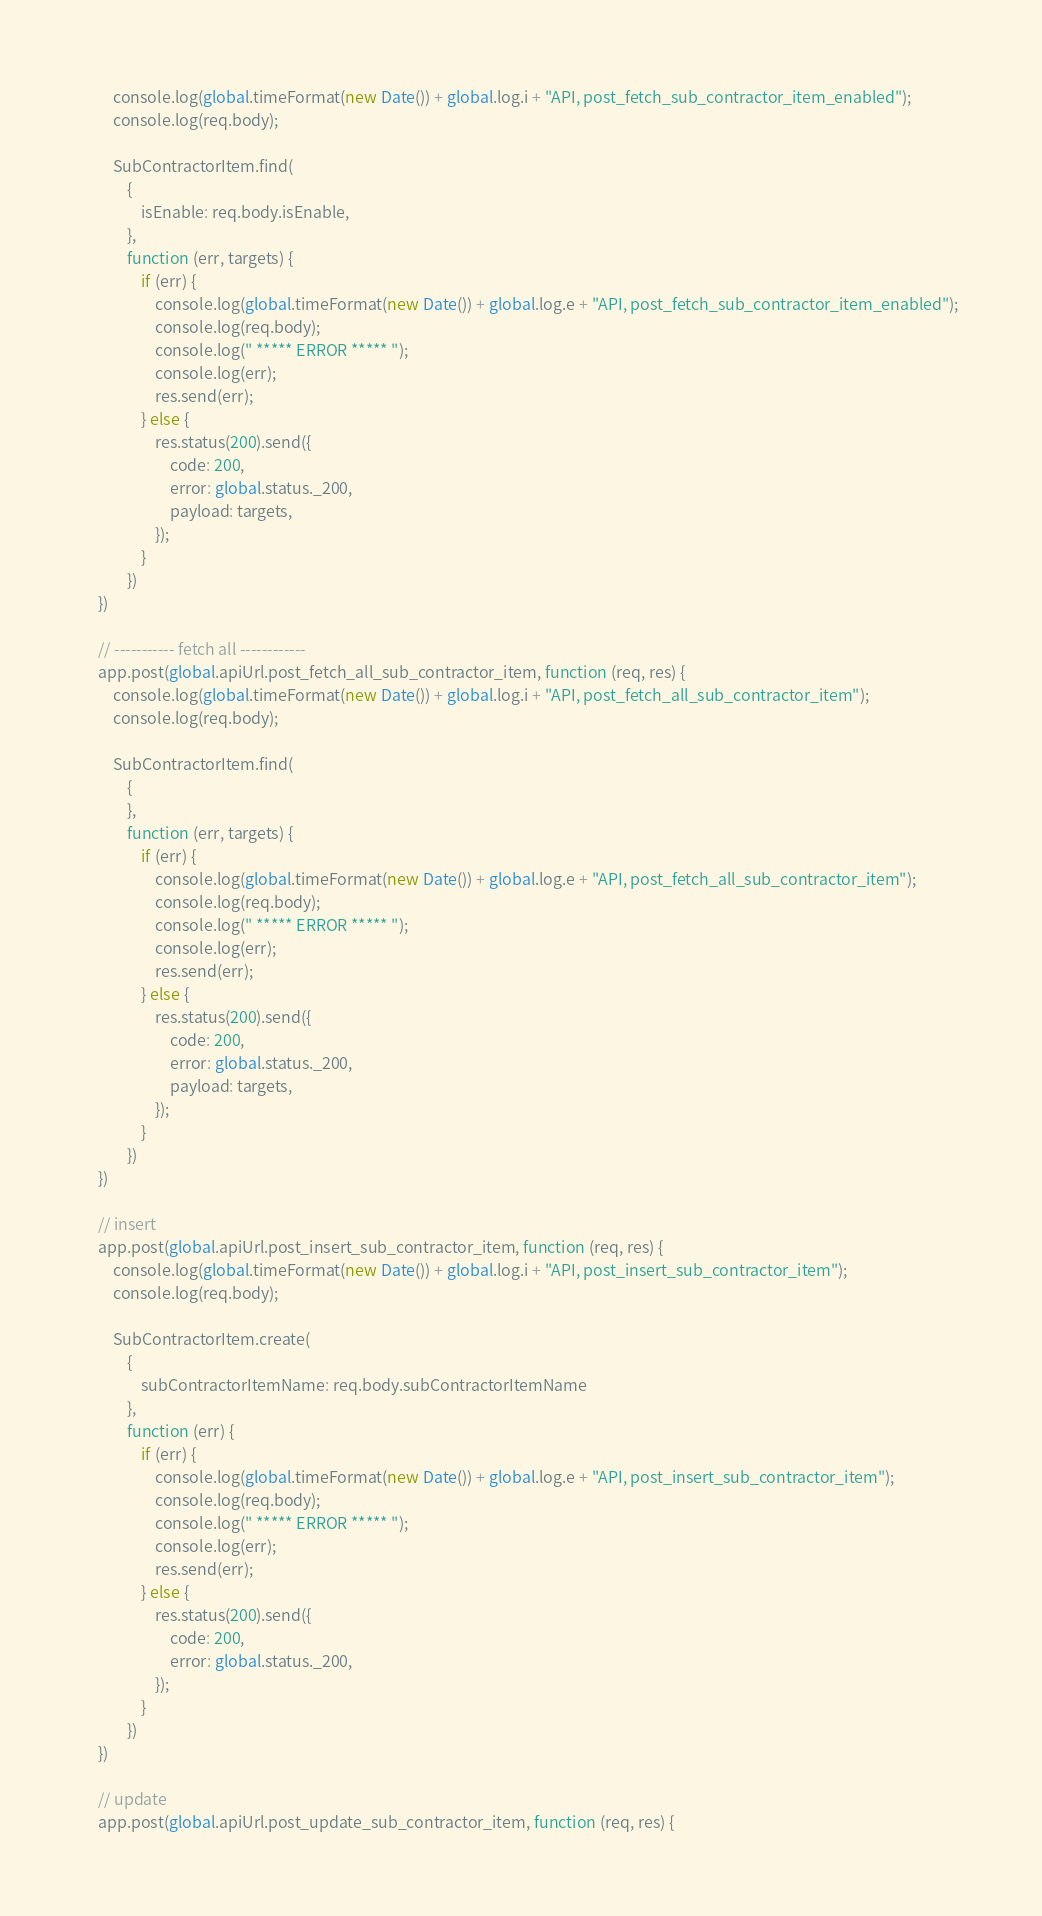Convert code to text. <code><loc_0><loc_0><loc_500><loc_500><_JavaScript_>        console.log(global.timeFormat(new Date()) + global.log.i + "API, post_fetch_sub_contractor_item_enabled");
        console.log(req.body);

        SubContractorItem.find(
            {
                isEnable: req.body.isEnable,
            },
            function (err, targets) {
                if (err) {
                    console.log(global.timeFormat(new Date()) + global.log.e + "API, post_fetch_sub_contractor_item_enabled");
                    console.log(req.body);
                    console.log(" ***** ERROR ***** ");
                    console.log(err);
                    res.send(err);
                } else {
                    res.status(200).send({
                        code: 200,
                        error: global.status._200,
                        payload: targets,
                    });
                }
            })
    })

    // ----------- fetch all ------------
    app.post(global.apiUrl.post_fetch_all_sub_contractor_item, function (req, res) {
        console.log(global.timeFormat(new Date()) + global.log.i + "API, post_fetch_all_sub_contractor_item");
        console.log(req.body);

        SubContractorItem.find(
            {
            },
            function (err, targets) {
                if (err) {
                    console.log(global.timeFormat(new Date()) + global.log.e + "API, post_fetch_all_sub_contractor_item");
                    console.log(req.body);
                    console.log(" ***** ERROR ***** ");
                    console.log(err);
                    res.send(err);
                } else {
                    res.status(200).send({
                        code: 200,
                        error: global.status._200,
                        payload: targets,
                    });
                }
            })
    })

    // insert
    app.post(global.apiUrl.post_insert_sub_contractor_item, function (req, res) {
        console.log(global.timeFormat(new Date()) + global.log.i + "API, post_insert_sub_contractor_item");
        console.log(req.body);

        SubContractorItem.create(
            {
                subContractorItemName: req.body.subContractorItemName
            },
            function (err) {
                if (err) {
                    console.log(global.timeFormat(new Date()) + global.log.e + "API, post_insert_sub_contractor_item");
                    console.log(req.body);
                    console.log(" ***** ERROR ***** ");
                    console.log(err);
                    res.send(err);
                } else {
                    res.status(200).send({
                        code: 200,
                        error: global.status._200,
                    });
                }
            })
    })

    // update
    app.post(global.apiUrl.post_update_sub_contractor_item, function (req, res) {</code> 